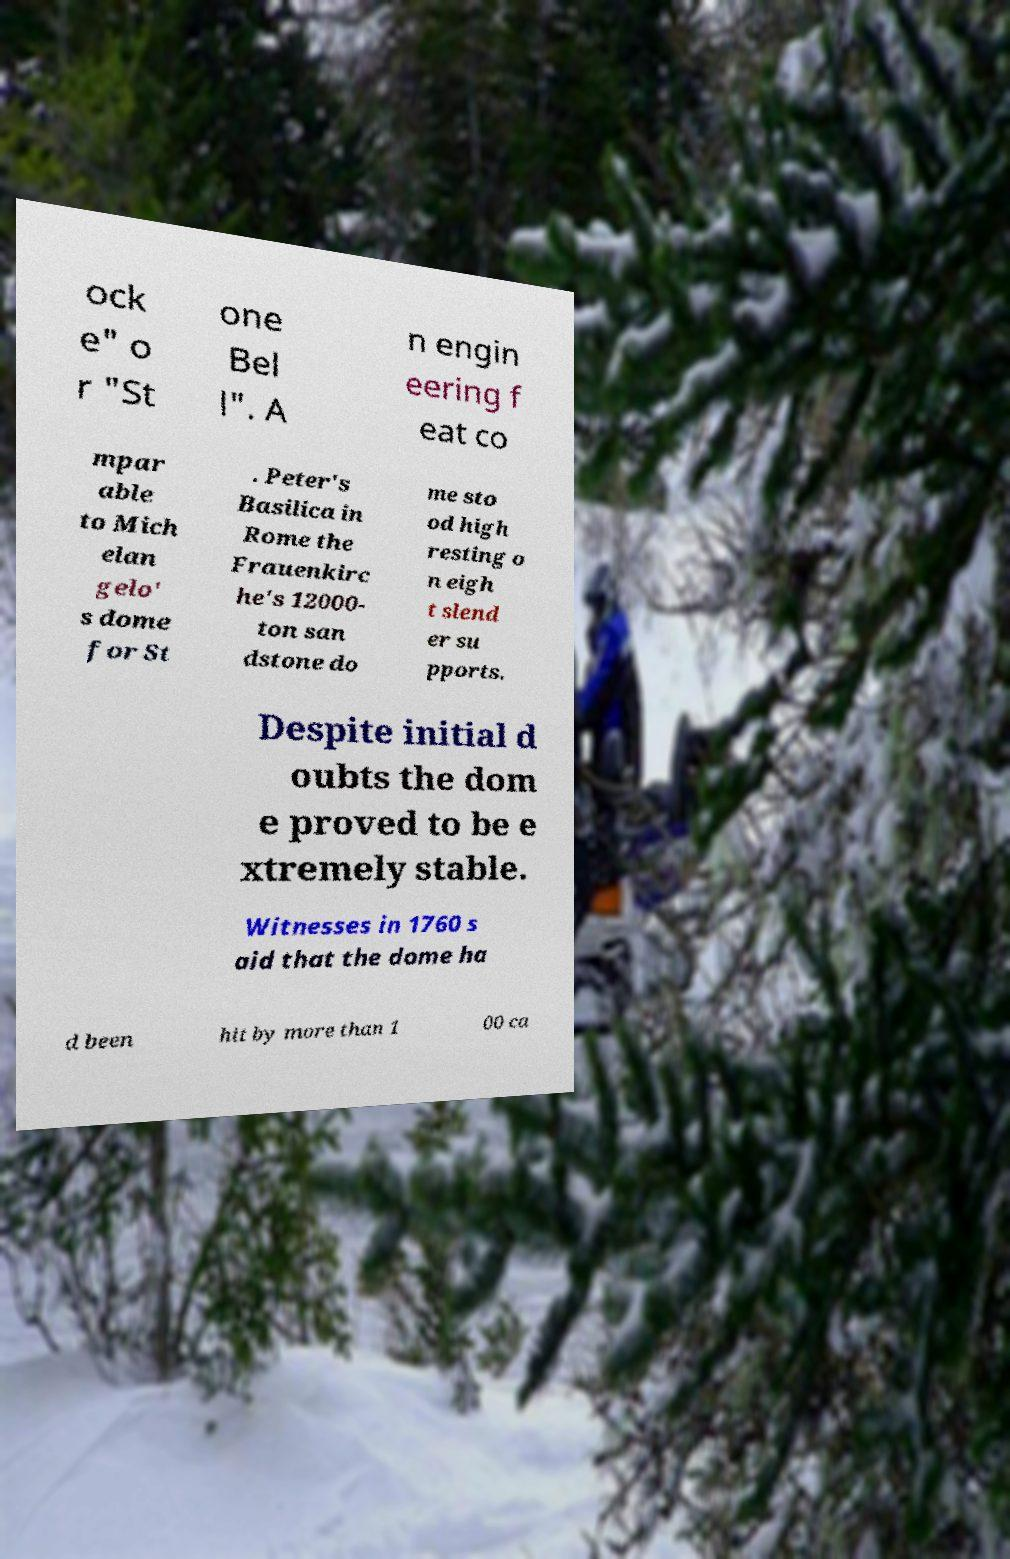What messages or text are displayed in this image? I need them in a readable, typed format. ock e" o r "St one Bel l". A n engin eering f eat co mpar able to Mich elan gelo' s dome for St . Peter's Basilica in Rome the Frauenkirc he's 12000- ton san dstone do me sto od high resting o n eigh t slend er su pports. Despite initial d oubts the dom e proved to be e xtremely stable. Witnesses in 1760 s aid that the dome ha d been hit by more than 1 00 ca 